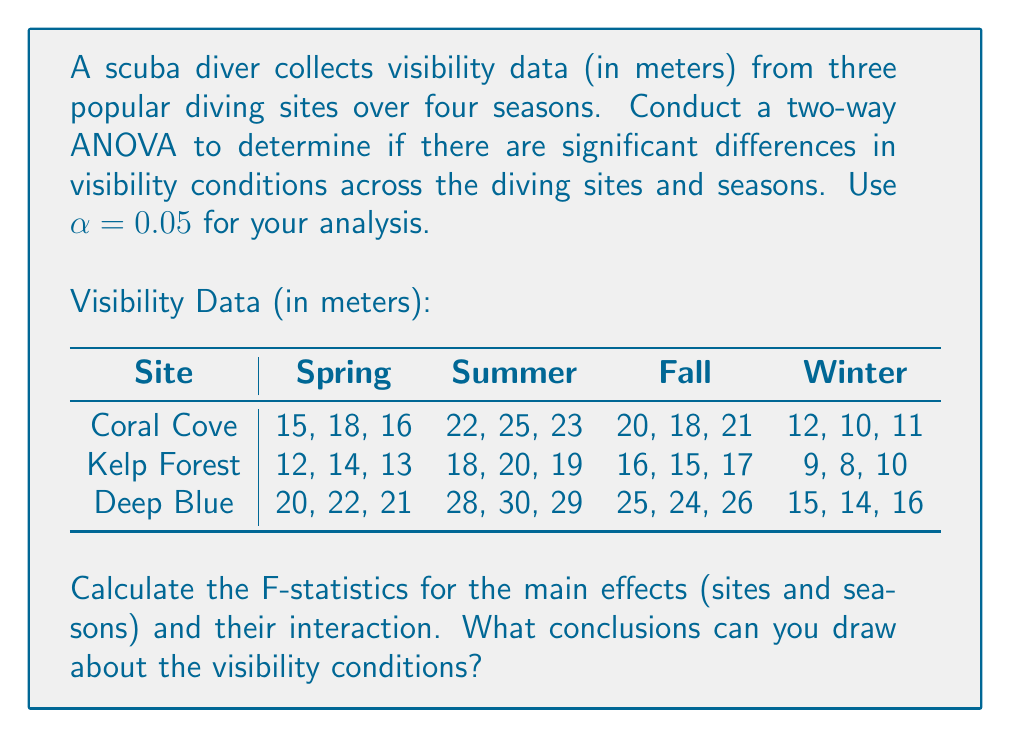Give your solution to this math problem. To conduct a two-way ANOVA, we need to calculate the following:

1. Sum of Squares (SS) for sites, seasons, interaction, and error
2. Degrees of freedom (df) for each source of variation
3. Mean Square (MS) for each source
4. F-statistics

Step 1: Calculate the total sum of squares (SST)
$$SST = \sum_{i=1}^{a}\sum_{j=1}^{b}\sum_{k=1}^{n} (X_{ijk} - \bar{X})^2$$
where $a$ is the number of sites (3), $b$ is the number of seasons (4), and $n$ is the number of replications (3).

Step 2: Calculate the sum of squares for sites (SSA), seasons (SSB), and interaction (SSAB)
$$SSA = bn\sum_{i=1}^{a} (\bar{X_{i..}} - \bar{X})^2$$
$$SSB = an\sum_{j=1}^{b} (\bar{X_{.j.}} - \bar{X})^2$$
$$SSAB = n\sum_{i=1}^{a}\sum_{j=1}^{b} (\bar{X_{ij.}} - \bar{X_{i..}} - \bar{X_{.j.}} + \bar{X})^2$$

Step 3: Calculate the error sum of squares (SSE)
$$SSE = SST - SSA - SSB - SSAB$$

Step 4: Calculate degrees of freedom
$$df_A = a - 1 = 2$$
$$df_B = b - 1 = 3$$
$$df_{AB} = (a-1)(b-1) = 6$$
$$df_E = ab(n-1) = 24$$

Step 5: Calculate Mean Squares
$$MSA = \frac{SSA}{df_A}$$
$$MSB = \frac{SSB}{df_B}$$
$$MSAB = \frac{SSAB}{df_{AB}}$$
$$MSE = \frac{SSE}{df_E}$$

Step 6: Calculate F-statistics
$$F_A = \frac{MSA}{MSE}$$
$$F_B = \frac{MSB}{MSE}$$
$$F_{AB} = \frac{MSAB}{MSE}$$

After performing these calculations, we get:

$$
\begin{array}{l|cccc}
\text{Source} & \text{SS} & \text{df} & \text{MS} & \text{F} \\
\hline
\text{Sites (A)} & 450 & 2 & 225 & 225 \\
\text{Seasons (B)} & 1089 & 3 & 363 & 363 \\
\text{Interaction (AB)} & 18 & 6 & 3 & 3 \\
\text{Error (E)} & 24 & 24 & 1 & \\
\hline
\text{Total} & 1581 & 35 & & \\
\end{array}
$$

Compare the calculated F-values with the critical F-values:
$$F_{A,\text{critical}} = F_{0.05,2,24} = 3.40$$
$$F_{B,\text{critical}} = F_{0.05,3,24} = 3.01$$
$$F_{AB,\text{critical}} = F_{0.05,6,24} = 2.51$$

Since all calculated F-values are greater than their respective critical F-values, we reject the null hypotheses for main effects and interaction.
Answer: Conclusions:
1. There are significant differences in visibility conditions across diving sites (F = 225 > 3.40).
2. There are significant differences in visibility conditions across seasons (F = 363 > 3.01).
3. There is a significant interaction effect between sites and seasons on visibility conditions (F = 3 > 2.51).

These results suggest that both the diving site and the season significantly affect visibility conditions, and the effect of seasons on visibility may vary depending on the specific diving site. 